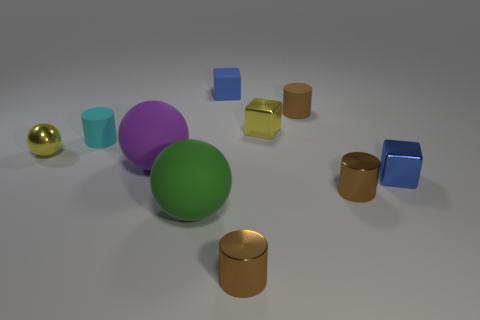How many brown cylinders must be subtracted to get 1 brown cylinders? 2 Subtract all purple balls. How many brown cylinders are left? 3 Subtract all spheres. How many objects are left? 7 Add 6 large green spheres. How many large green spheres exist? 7 Subtract 0 purple cubes. How many objects are left? 10 Subtract all large brown shiny cylinders. Subtract all big purple balls. How many objects are left? 9 Add 2 small cyan cylinders. How many small cyan cylinders are left? 3 